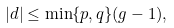<formula> <loc_0><loc_0><loc_500><loc_500>| d | \leq \min \{ p , q \} ( g - 1 ) ,</formula> 